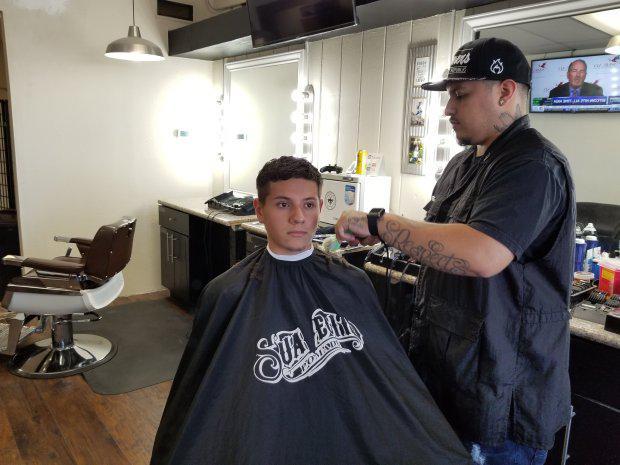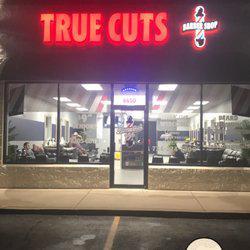The first image is the image on the left, the second image is the image on the right. Analyze the images presented: Is the assertion "A barber in a baseball cap is cutting a mans hair, the person getting their hair cut is wearing a protective cover to shield from the falling hair" valid? Answer yes or no. Yes. 